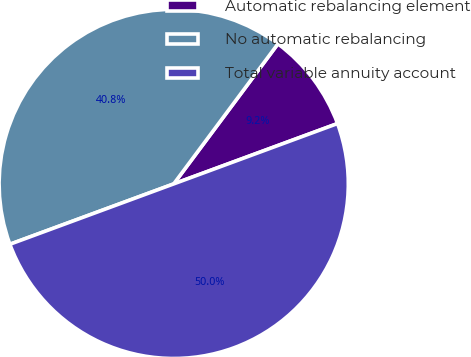<chart> <loc_0><loc_0><loc_500><loc_500><pie_chart><fcel>Automatic rebalancing element<fcel>No automatic rebalancing<fcel>Total variable annuity account<nl><fcel>9.2%<fcel>40.8%<fcel>50.0%<nl></chart> 